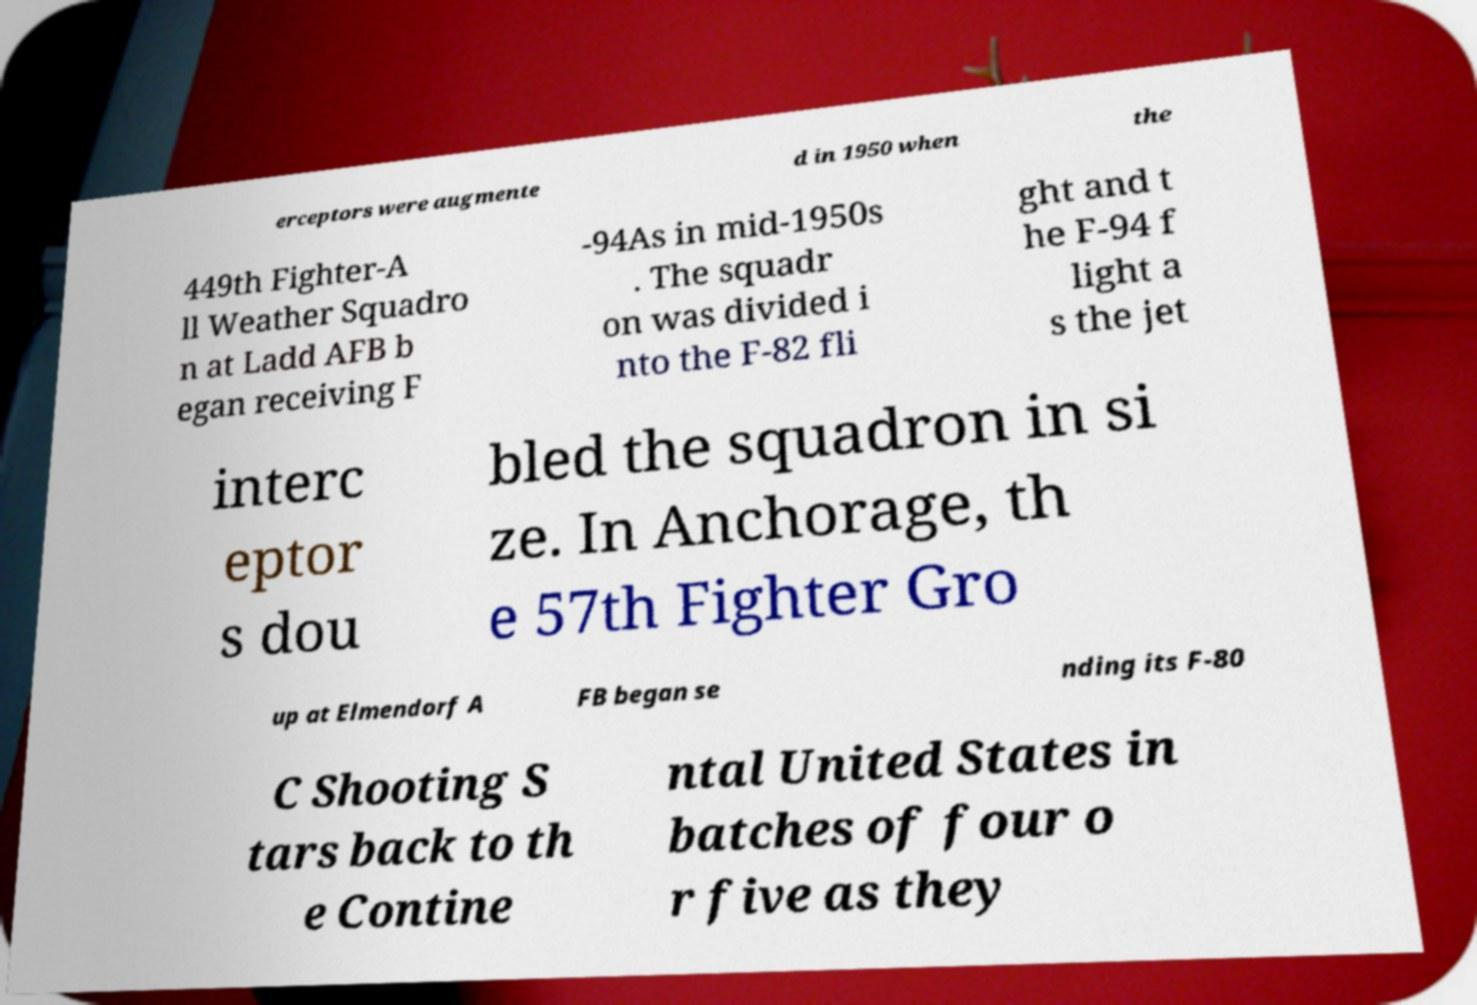There's text embedded in this image that I need extracted. Can you transcribe it verbatim? erceptors were augmente d in 1950 when the 449th Fighter-A ll Weather Squadro n at Ladd AFB b egan receiving F -94As in mid-1950s . The squadr on was divided i nto the F-82 fli ght and t he F-94 f light a s the jet interc eptor s dou bled the squadron in si ze. In Anchorage, th e 57th Fighter Gro up at Elmendorf A FB began se nding its F-80 C Shooting S tars back to th e Contine ntal United States in batches of four o r five as they 